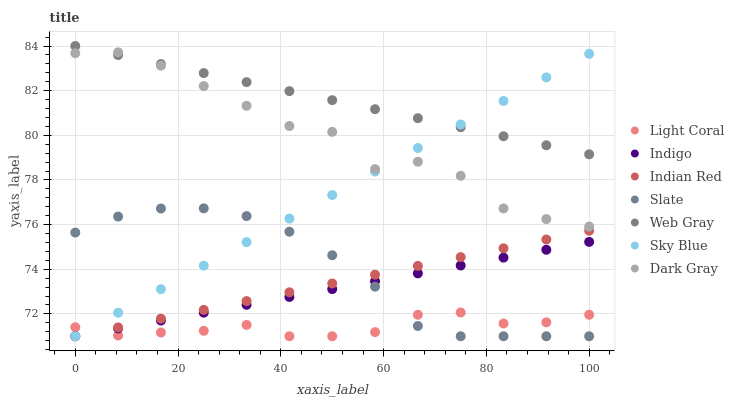Does Light Coral have the minimum area under the curve?
Answer yes or no. Yes. Does Web Gray have the maximum area under the curve?
Answer yes or no. Yes. Does Indigo have the minimum area under the curve?
Answer yes or no. No. Does Indigo have the maximum area under the curve?
Answer yes or no. No. Is Indian Red the smoothest?
Answer yes or no. Yes. Is Dark Gray the roughest?
Answer yes or no. Yes. Is Web Gray the smoothest?
Answer yes or no. No. Is Web Gray the roughest?
Answer yes or no. No. Does Indigo have the lowest value?
Answer yes or no. Yes. Does Web Gray have the lowest value?
Answer yes or no. No. Does Web Gray have the highest value?
Answer yes or no. Yes. Does Indigo have the highest value?
Answer yes or no. No. Is Indigo less than Web Gray?
Answer yes or no. Yes. Is Dark Gray greater than Slate?
Answer yes or no. Yes. Does Sky Blue intersect Light Coral?
Answer yes or no. Yes. Is Sky Blue less than Light Coral?
Answer yes or no. No. Is Sky Blue greater than Light Coral?
Answer yes or no. No. Does Indigo intersect Web Gray?
Answer yes or no. No. 